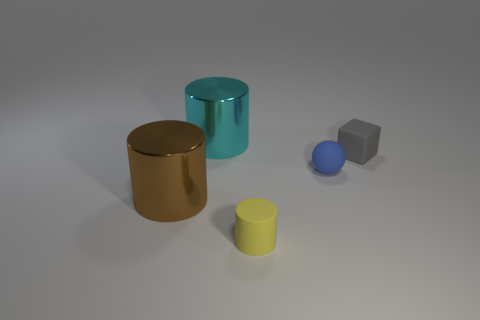Subtract all big shiny cylinders. How many cylinders are left? 1 Add 1 rubber cylinders. How many objects exist? 6 Subtract all yellow cylinders. How many cylinders are left? 2 Subtract all green balls. How many brown cylinders are left? 1 Add 1 big cyan cylinders. How many big cyan cylinders exist? 2 Subtract 0 red cylinders. How many objects are left? 5 Subtract all cylinders. How many objects are left? 2 Subtract all purple balls. Subtract all gray blocks. How many balls are left? 1 Subtract all blue metallic objects. Subtract all rubber spheres. How many objects are left? 4 Add 1 matte cylinders. How many matte cylinders are left? 2 